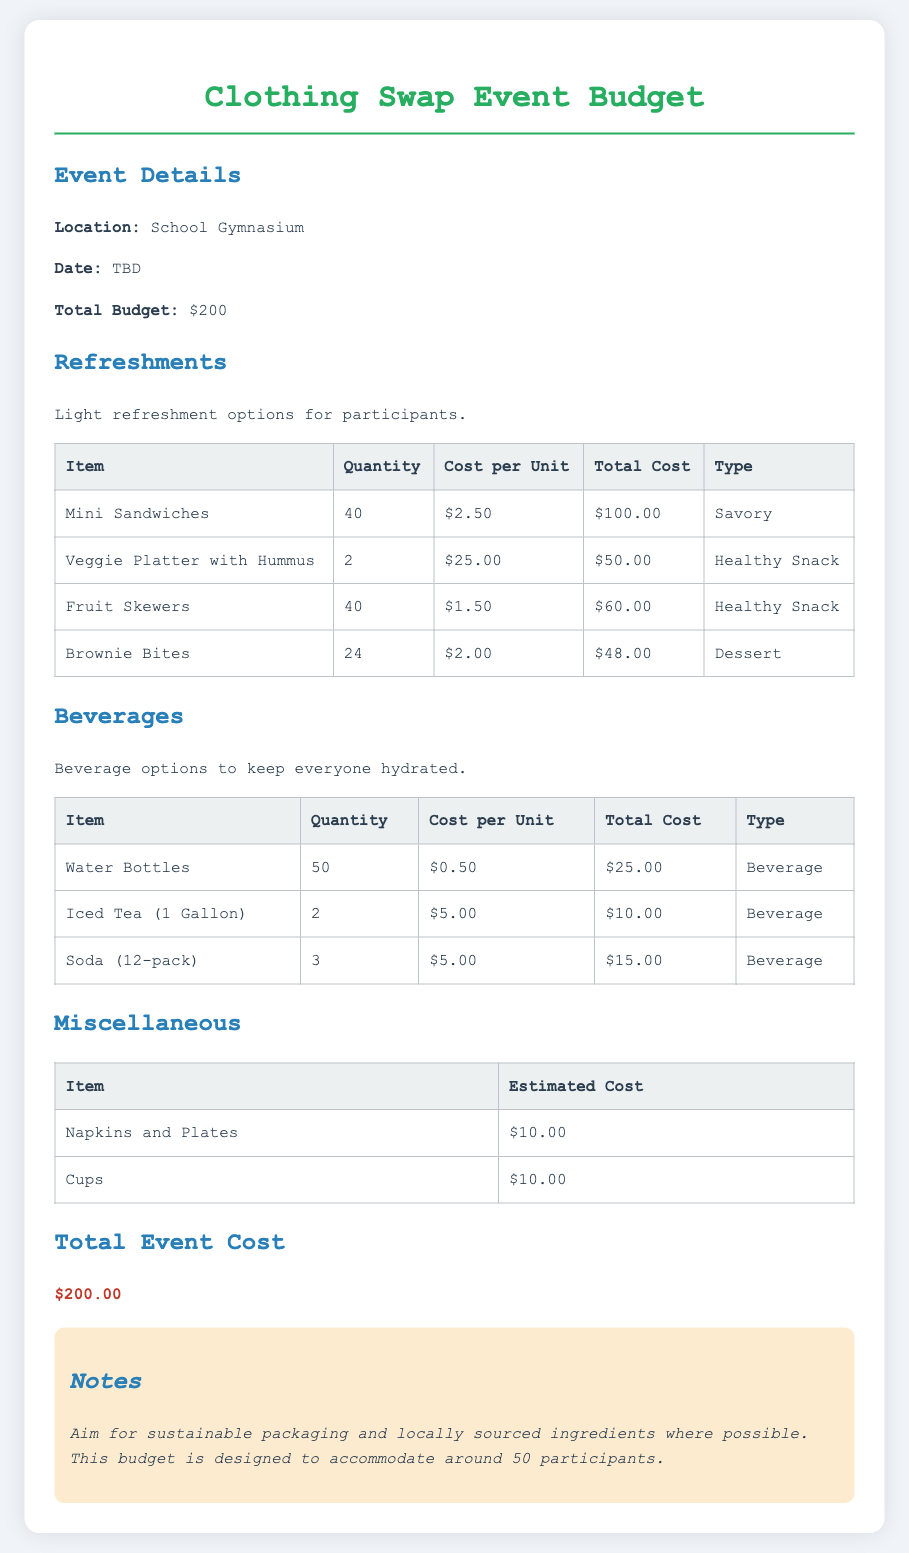What is the total budget? The total budget for the event is stated clearly in the document as $200.
Answer: $200 How many mini sandwiches are being provided? The document specifies that 40 mini sandwiches will be available for the event.
Answer: 40 What is the cost of the veggie platter with hummus? The cost for the veggie platter with hummus is mentioned as $50.00 in total.
Answer: $50.00 How many gallons of iced tea are being served? The budget outlines that 2 gallons of iced tea will be provided at the event.
Answer: 2 What type of snacks are included in the budget? The document lists various types of snacks like savory, healthy snacks, and dessert, indicating a variety of food options.
Answer: Savory, Healthy Snack, Dessert What is the total cost of beverages? The total cost of beverages is calculated from the individual items listed in the beverages section, which adds up to $50.00.
Answer: $50.00 How much is allocated for napkins and plates? The budget specifies that $10.00 is assigned to napkins and plates.
Answer: $10.00 What is suggested regarding packaging? The document notes the aim for sustainable packaging in the notes section.
Answer: Sustainable packaging How many participants is the budget designed to accommodate? The document mentions that the budget is intended to accommodate around 50 participants.
Answer: 50 